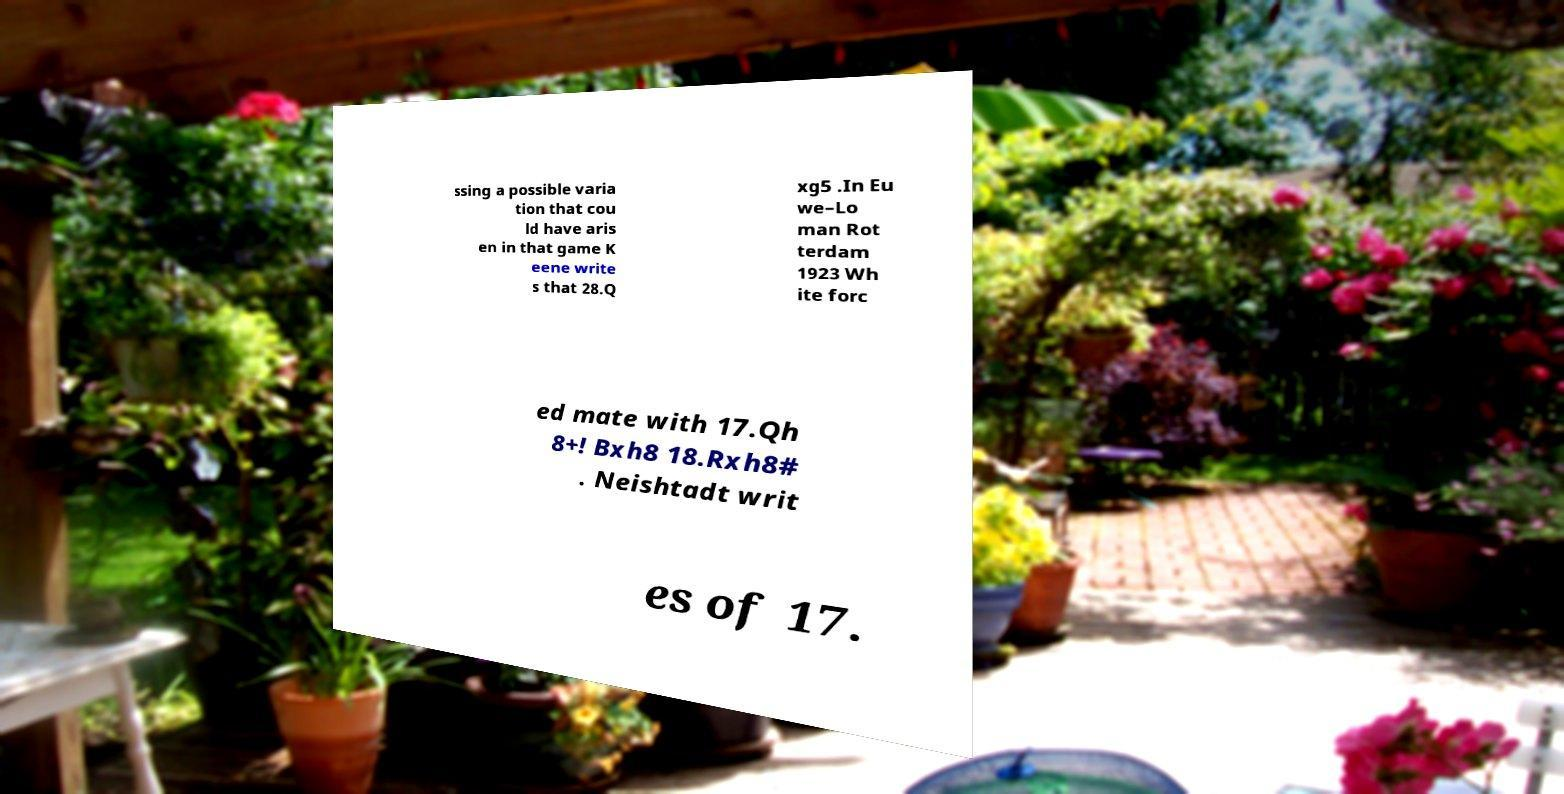I need the written content from this picture converted into text. Can you do that? ssing a possible varia tion that cou ld have aris en in that game K eene write s that 28.Q xg5 .In Eu we–Lo man Rot terdam 1923 Wh ite forc ed mate with 17.Qh 8+! Bxh8 18.Rxh8# . Neishtadt writ es of 17. 